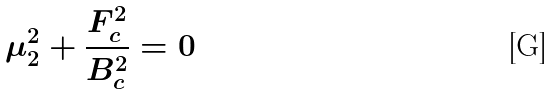Convert formula to latex. <formula><loc_0><loc_0><loc_500><loc_500>\mu _ { 2 } ^ { 2 } + \frac { F _ { c } ^ { 2 } } { B _ { c } ^ { 2 } } = 0</formula> 